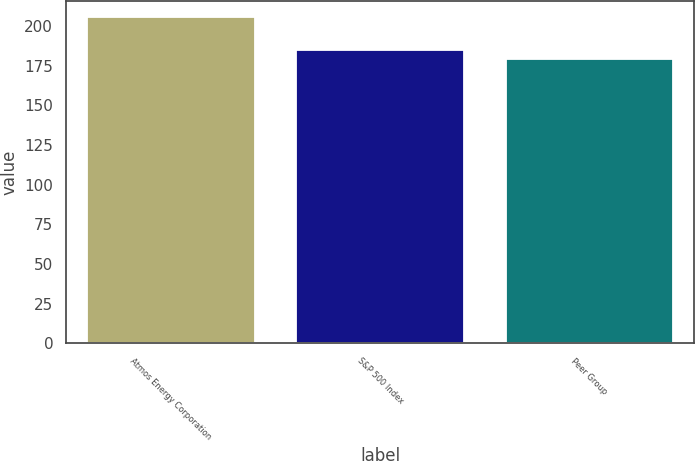Convert chart to OTSL. <chart><loc_0><loc_0><loc_500><loc_500><bar_chart><fcel>Atmos Energy Corporation<fcel>S&P 500 Index<fcel>Peer Group<nl><fcel>205.6<fcel>184.91<fcel>179.33<nl></chart> 